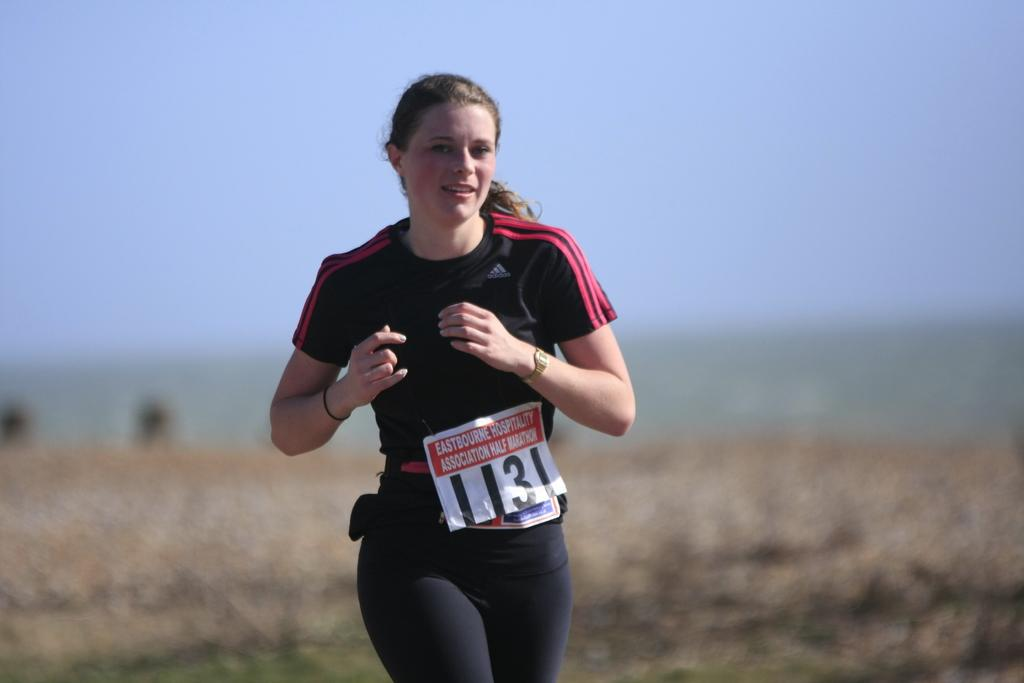Who is the main subject in the image? There is a woman in the image. What is the woman wearing? The woman is wearing clothes and a wristwatch. What is the woman's facial expression? The woman is smiling. What is the woman doing in the image? The woman is running. Can you describe the background of the image? The background of the image is blurred. What does the woman regret in the image? There is no indication in the image that the woman is experiencing regret, as she is smiling and running. 